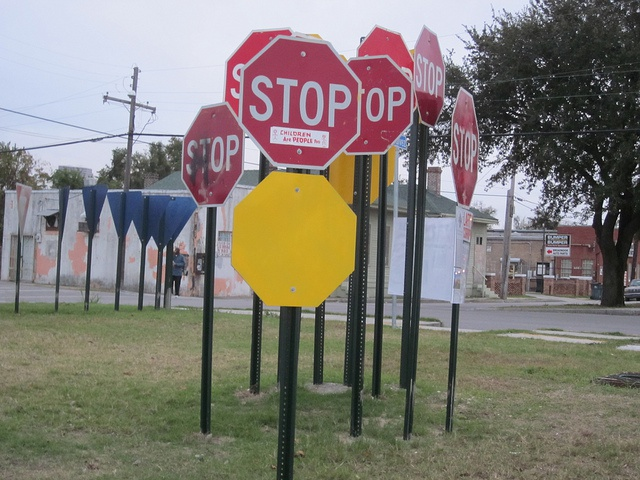Describe the objects in this image and their specific colors. I can see stop sign in lavender, brown, and darkgray tones, stop sign in lavender, brown, darkgray, and purple tones, stop sign in lavender, brown, and darkgray tones, stop sign in lavender, brown, and darkgray tones, and stop sign in lavender, darkgray, gray, and maroon tones in this image. 